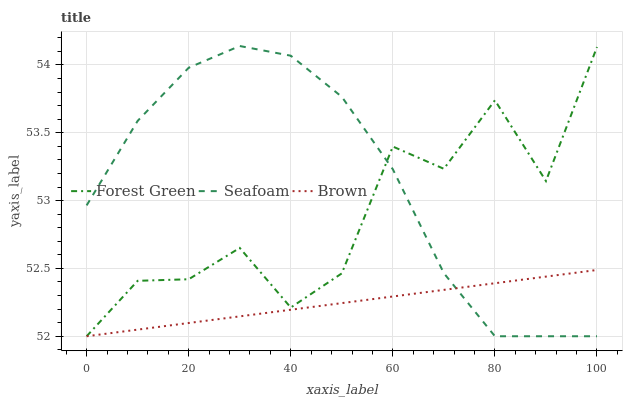Does Brown have the minimum area under the curve?
Answer yes or no. Yes. Does Seafoam have the maximum area under the curve?
Answer yes or no. Yes. Does Forest Green have the minimum area under the curve?
Answer yes or no. No. Does Forest Green have the maximum area under the curve?
Answer yes or no. No. Is Brown the smoothest?
Answer yes or no. Yes. Is Forest Green the roughest?
Answer yes or no. Yes. Is Seafoam the smoothest?
Answer yes or no. No. Is Seafoam the roughest?
Answer yes or no. No. Does Seafoam have the highest value?
Answer yes or no. Yes. Does Forest Green have the highest value?
Answer yes or no. No. Does Forest Green intersect Brown?
Answer yes or no. Yes. Is Forest Green less than Brown?
Answer yes or no. No. Is Forest Green greater than Brown?
Answer yes or no. No. 